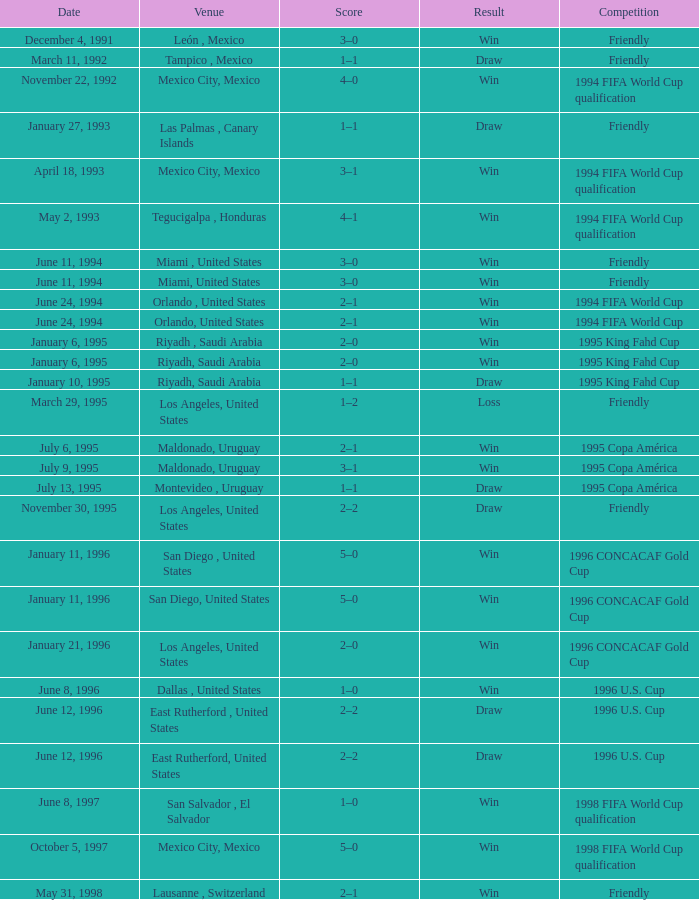When the venue is riyadh, saudi arabia and the result indicates a "win," what is the score? 2–0, 2–0. 